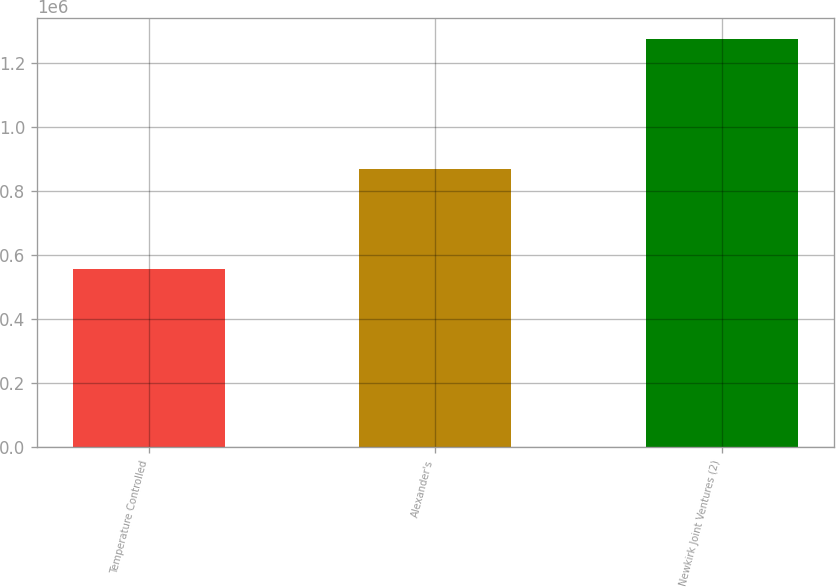Convert chart to OTSL. <chart><loc_0><loc_0><loc_500><loc_500><bar_chart><fcel>Temperature Controlled<fcel>Alexander's<fcel>Newkirk Joint Ventures (2)<nl><fcel>557017<fcel>870073<fcel>1.2769e+06<nl></chart> 